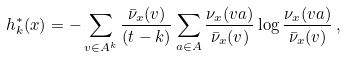Convert formula to latex. <formula><loc_0><loc_0><loc_500><loc_500>h ^ { * } _ { k } ( x ) = - \sum _ { v \in A ^ { k } } \frac { \bar { \nu } _ { x } ( v ) } { ( t - k ) } \sum _ { a \in A } \frac { \nu _ { x } ( v a ) } { \bar { \nu } _ { x } ( v ) } \log \frac { \nu _ { x } ( v a ) } { \bar { \nu } _ { x } ( v ) } \, ,</formula> 